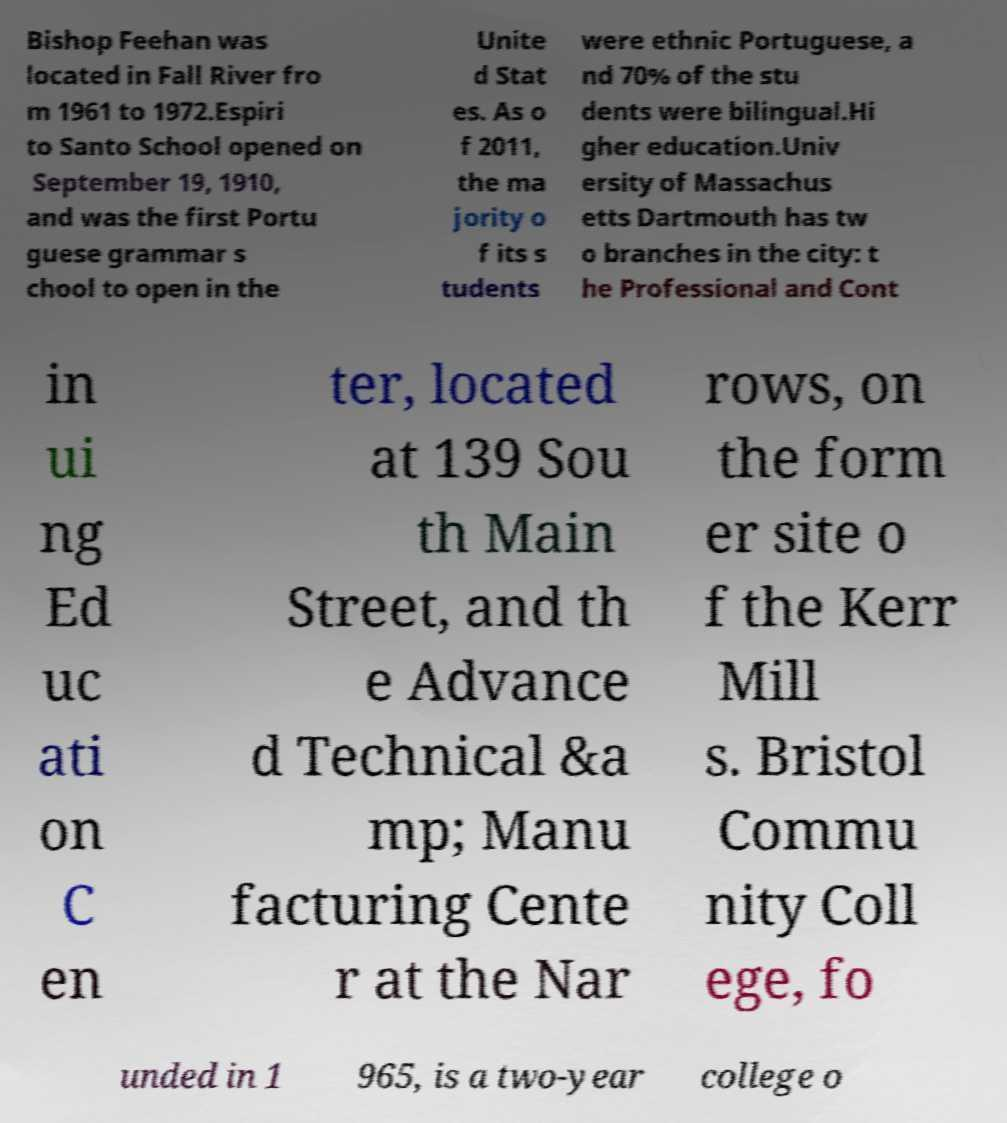Can you read and provide the text displayed in the image?This photo seems to have some interesting text. Can you extract and type it out for me? Bishop Feehan was located in Fall River fro m 1961 to 1972.Espiri to Santo School opened on September 19, 1910, and was the first Portu guese grammar s chool to open in the Unite d Stat es. As o f 2011, the ma jority o f its s tudents were ethnic Portuguese, a nd 70% of the stu dents were bilingual.Hi gher education.Univ ersity of Massachus etts Dartmouth has tw o branches in the city: t he Professional and Cont in ui ng Ed uc ati on C en ter, located at 139 Sou th Main Street, and th e Advance d Technical &a mp; Manu facturing Cente r at the Nar rows, on the form er site o f the Kerr Mill s. Bristol Commu nity Coll ege, fo unded in 1 965, is a two-year college o 